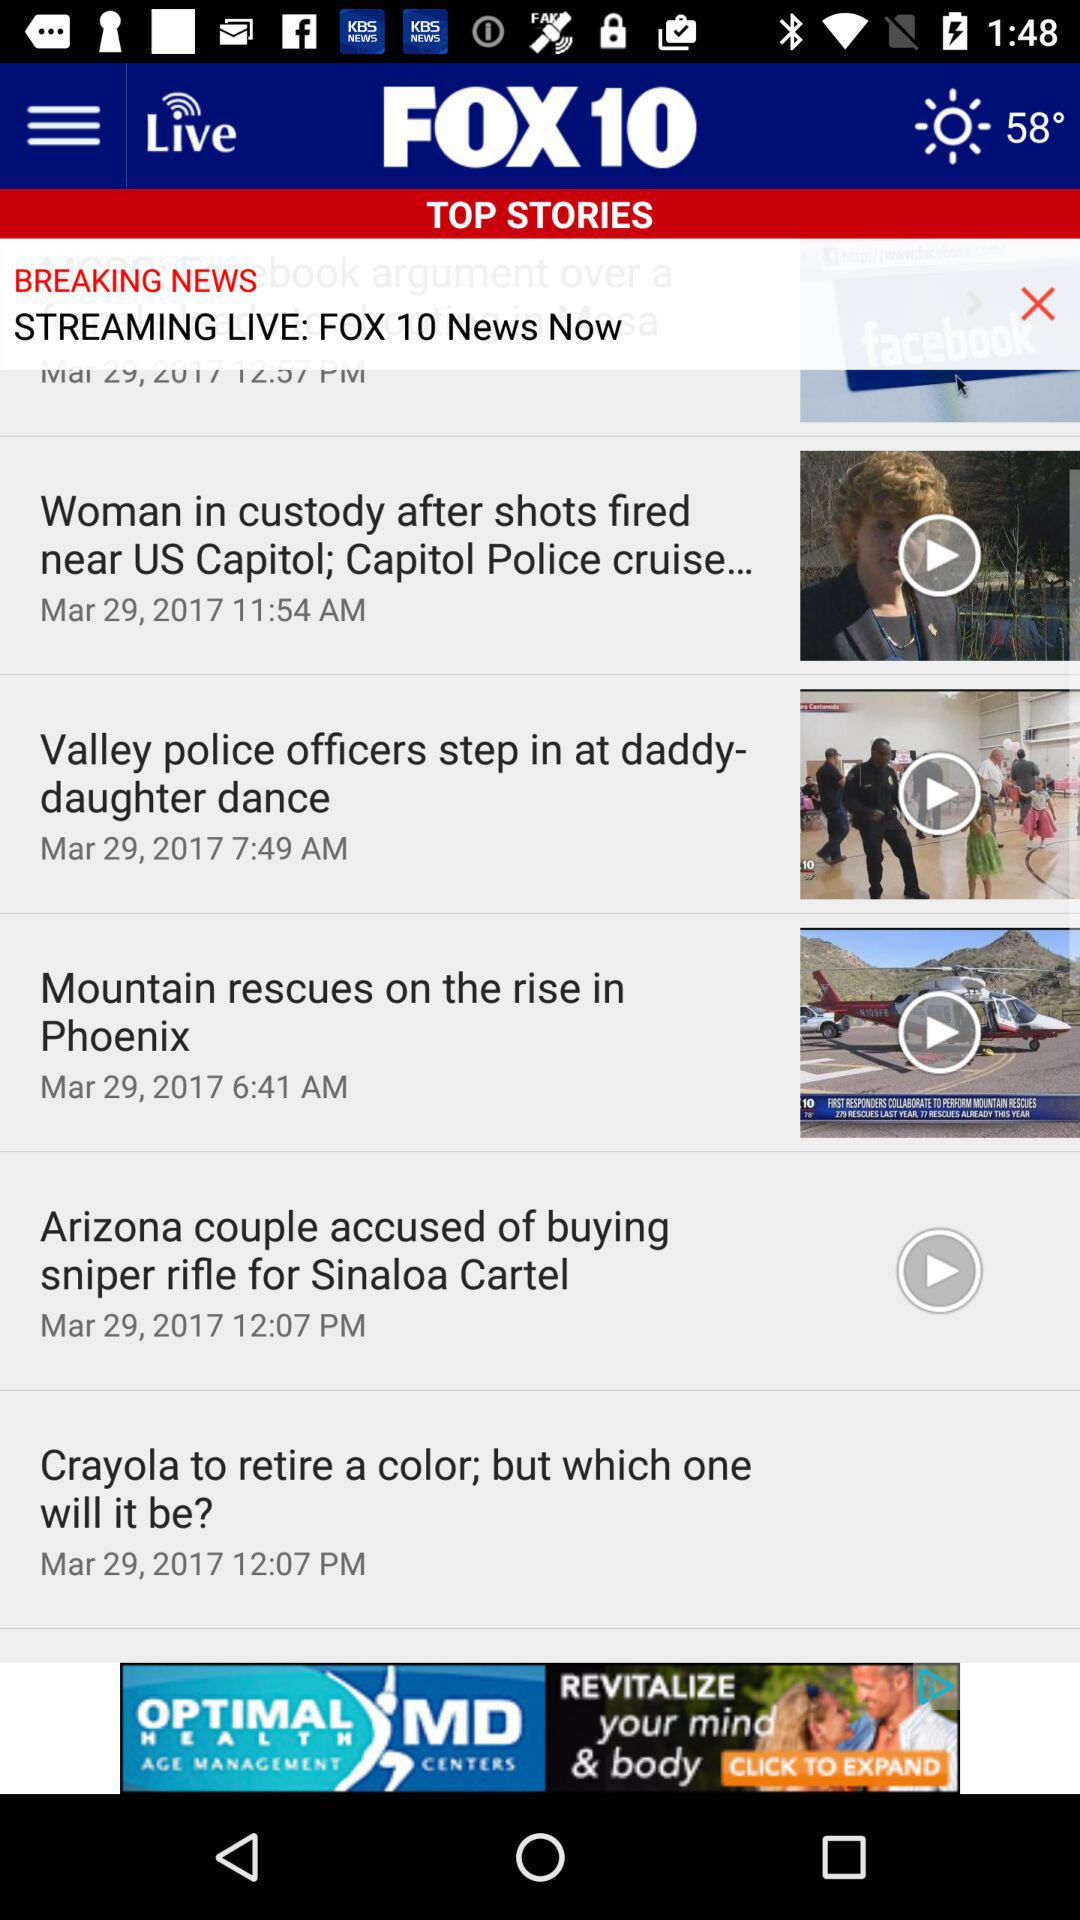What is the temperature? The temperature is 58°. 